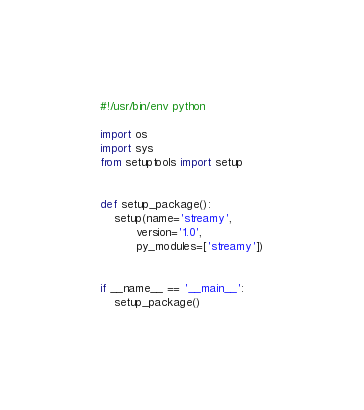<code> <loc_0><loc_0><loc_500><loc_500><_Python_>#!/usr/bin/env python

import os
import sys
from setuptools import setup


def setup_package():
    setup(name='streamy',
          version='1.0',
          py_modules=['streamy'])


if __name__ == '__main__':
    setup_package()
</code> 